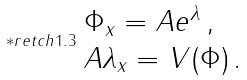Convert formula to latex. <formula><loc_0><loc_0><loc_500><loc_500>\ast r e t c h { 1 . 3 } \begin{array} { l } \Phi _ { x } = A e ^ { \lambda } \, , \\ A \lambda _ { x } = V ( \Phi ) \, . \end{array}</formula> 